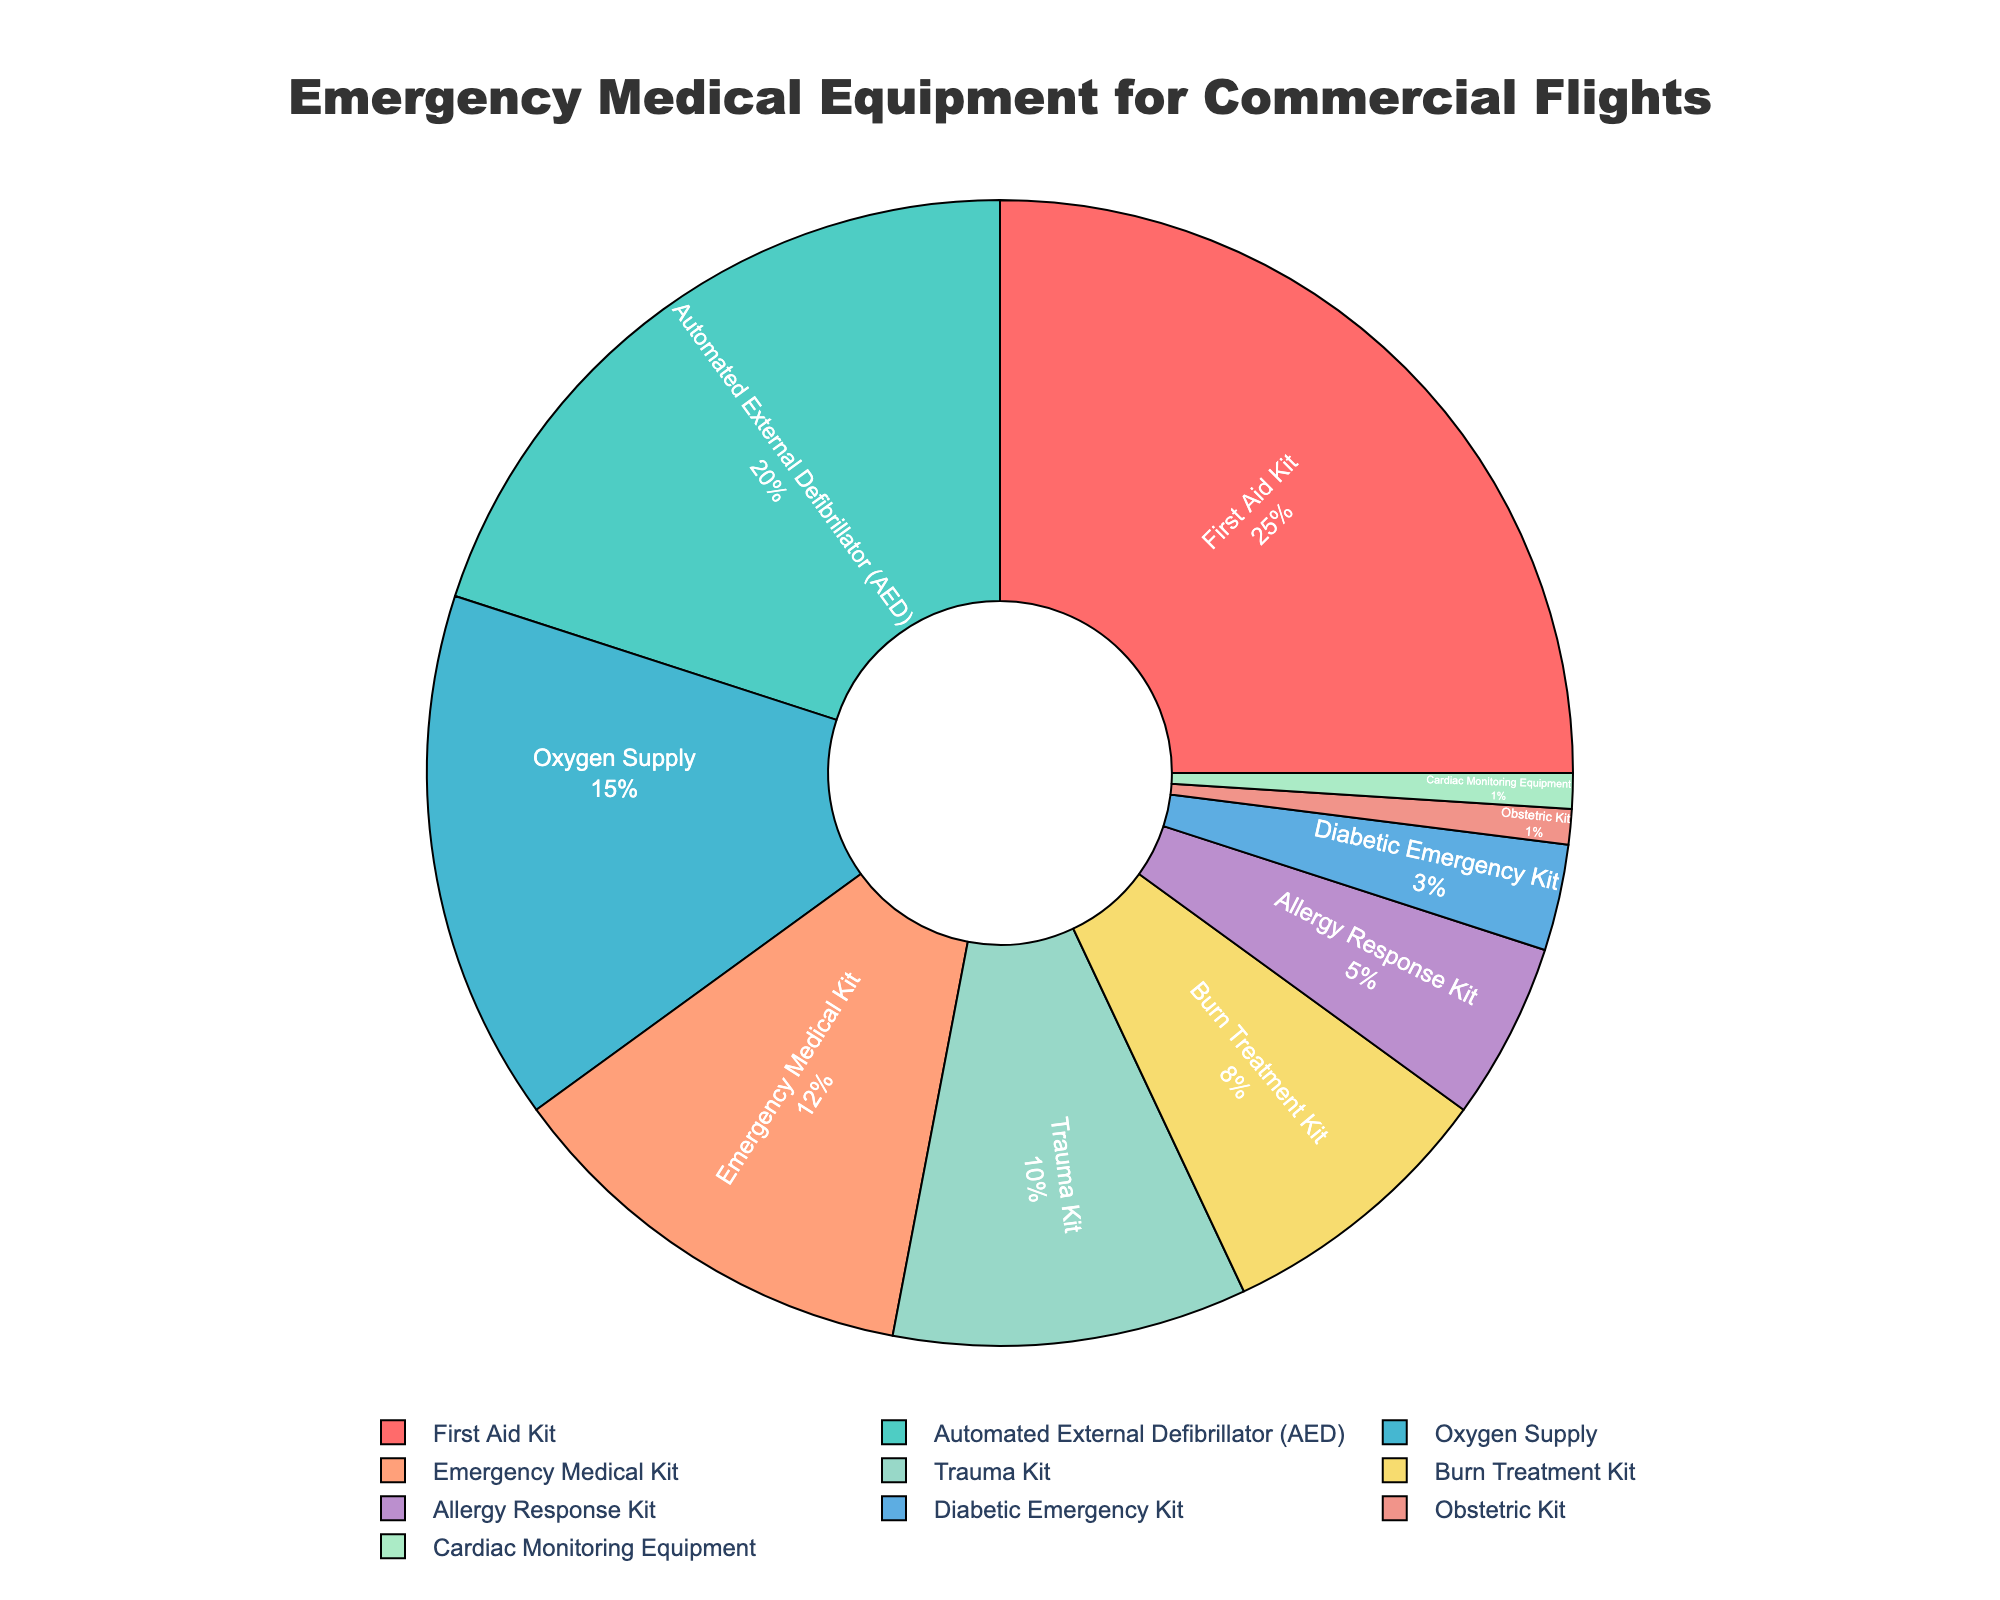Which category occupies the largest portion of the pie chart? By visually inspecting the pie chart, we can see that the 'First Aid Kit' occupies the largest portion at 25%.
Answer: First Aid Kit How much larger is the percentage of 'First Aid Kit' compared to 'Automated External Defibrillator (AED)'? 'First Aid Kit' is 25%, and 'Automated External Defibrillator (AED)' is 20%. Subtract 20% from 25% to get 5%.
Answer: 5% What is the total percentage for 'Oxygen Supply', 'Emergency Medical Kit', and 'Trauma Kit' combined? Add the percentages for 'Oxygen Supply' (15%), 'Emergency Medical Kit' (12%), and 'Trauma Kit' (10%). 15% + 12% + 10% = 37%.
Answer: 37% What is the percentage difference between 'Burn Treatment Kit' and 'Diabetic Emergency Kit'? 'Burn Treatment Kit' is 8%, and 'Diabetic Emergency Kit' is 3%. Subtract 3% from 8% to get 5%.
Answer: 5% Which has a smaller percentage, 'Obstetric Kit' or 'Cardiac Monitoring Equipment'? Both 'Obstetric Kit' and 'Cardiac Monitoring Equipment' have the same percentage, which is 1%.
Answer: Obstetric Kit and Cardiac Monitoring Equipment How does the percentage of 'Allergy Response Kit' compare to that of 'Trauma Kit'? 'Allergy Response Kit' is 5%, and 'Trauma Kit' is 10%. The 'Trauma Kit' has a higher percentage than the 'Allergy Response Kit'.
Answer: Allergy Response Kit has a smaller percentage What is the combined percentage of 'Burn Treatment Kit' and 'Allergy Response Kit'? Add the percentages for 'Burn Treatment Kit' (8%) and 'Allergy Response Kit' (5%). 8% + 5% = 13%.
Answer: 13% How much more, in percentage points, is the 'First Aid Kit' compared to the 'Obstetric Kit' and 'Cardiac Monitoring Equipment' combined? 'First Aid Kit' is 25%, while 'Obstetric Kit' and 'Cardiac Monitoring Equipment' combined is 1% + 1% = 2%. Subtract 2% from 25% to get 23%.
Answer: 23% Which category marked in blue has the next largest share after 'Automated External Defibrillator (AED)'? By inspecting the colors in the pie chart, the next largest blue-marked category after 'Automated External Defibrillator (AED)' (20%) is 'Emergency Medical Kit' with 12%.
Answer: Emergency Medical Kit 